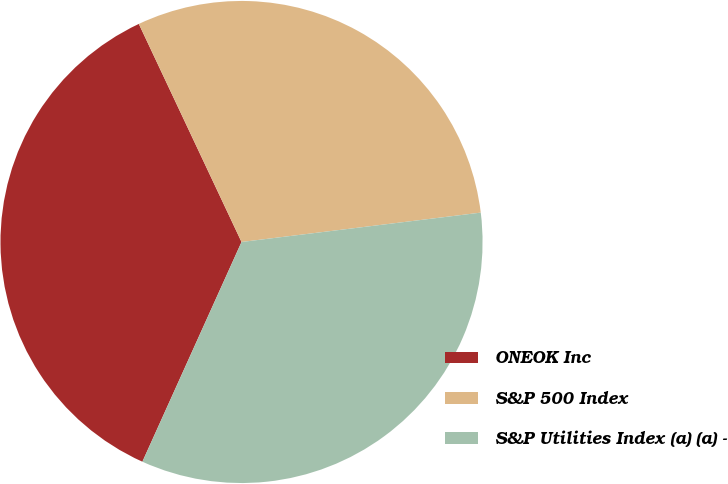Convert chart. <chart><loc_0><loc_0><loc_500><loc_500><pie_chart><fcel>ONEOK Inc<fcel>S&P 500 Index<fcel>S&P Utilities Index (a) (a) -<nl><fcel>36.25%<fcel>30.06%<fcel>33.69%<nl></chart> 